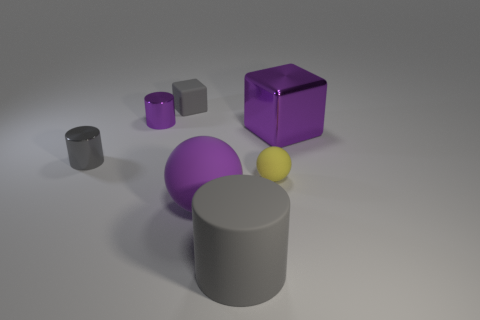Subtract all large cylinders. How many cylinders are left? 2 Subtract all purple cylinders. How many cylinders are left? 2 Subtract 2 balls. How many balls are left? 0 Subtract all blocks. How many objects are left? 5 Add 1 matte cubes. How many objects exist? 8 Add 3 cyan cubes. How many cyan cubes exist? 3 Subtract 0 red cylinders. How many objects are left? 7 Subtract all cyan cylinders. Subtract all cyan balls. How many cylinders are left? 3 Subtract all yellow spheres. How many purple cubes are left? 1 Subtract all large purple blocks. Subtract all big matte objects. How many objects are left? 4 